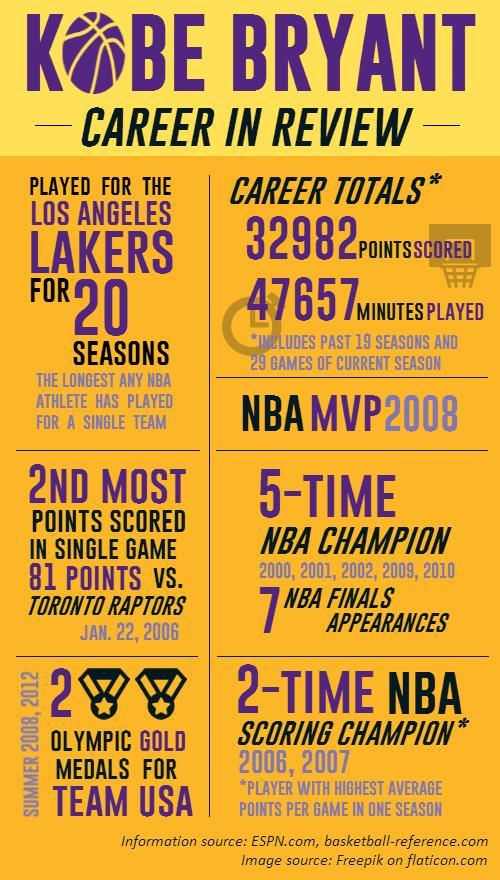In which all years Kobe Bryant got NBA scoring champion title?
Answer the question with a short phrase. 2006, 2007 In which all years Kobe Bryant got Olympic gold medals for Team USA? 2008, 2012 